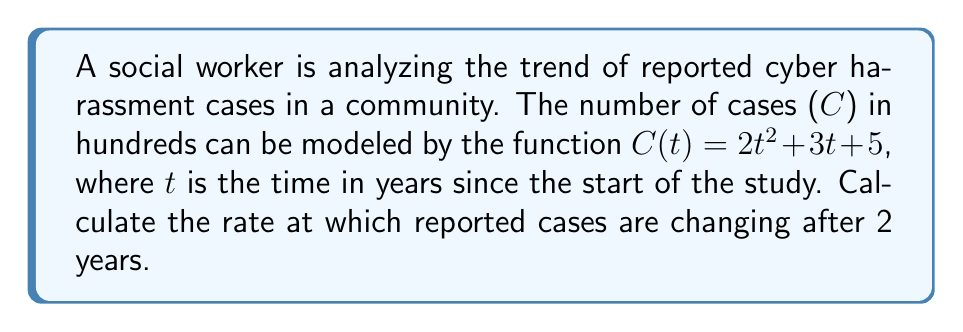Help me with this question. To find the rate at which reported cases are changing, we need to calculate the derivative of the given function and evaluate it at t = 2.

1. Given function: $C(t) = 2t^2 + 3t + 5$

2. To find the rate of change, we need to find $\frac{dC}{dt}$:
   $\frac{dC}{dt} = \frac{d}{dt}(2t^2 + 3t + 5)$

3. Using the power rule and constant rule of differentiation:
   $\frac{dC}{dt} = 4t + 3$

4. Now, we evaluate the derivative at t = 2:
   $\frac{dC}{dt}|_{t=2} = 4(2) + 3 = 8 + 3 = 11$

5. Interpret the result: The rate of change is 11 hundred cases per year at t = 2.
Answer: $11$ hundred cases per year 